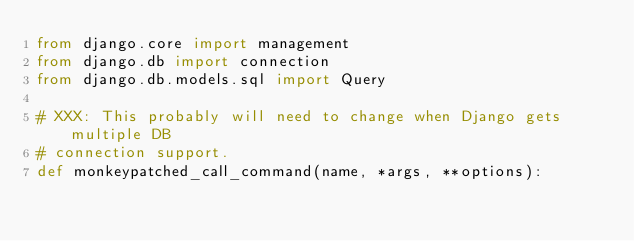Convert code to text. <code><loc_0><loc_0><loc_500><loc_500><_Python_>from django.core import management
from django.db import connection
from django.db.models.sql import Query

# XXX: This probably will need to change when Django gets multiple DB
# connection support.
def monkeypatched_call_command(name, *args, **options):</code> 